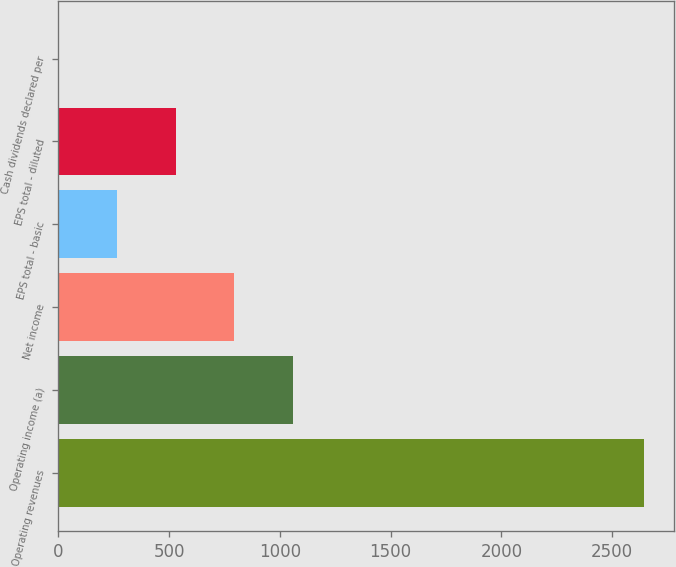Convert chart. <chart><loc_0><loc_0><loc_500><loc_500><bar_chart><fcel>Operating revenues<fcel>Operating income (a)<fcel>Net income<fcel>EPS total - basic<fcel>EPS total - diluted<fcel>Cash dividends declared per<nl><fcel>2645<fcel>1058.2<fcel>793.74<fcel>264.82<fcel>529.28<fcel>0.36<nl></chart> 